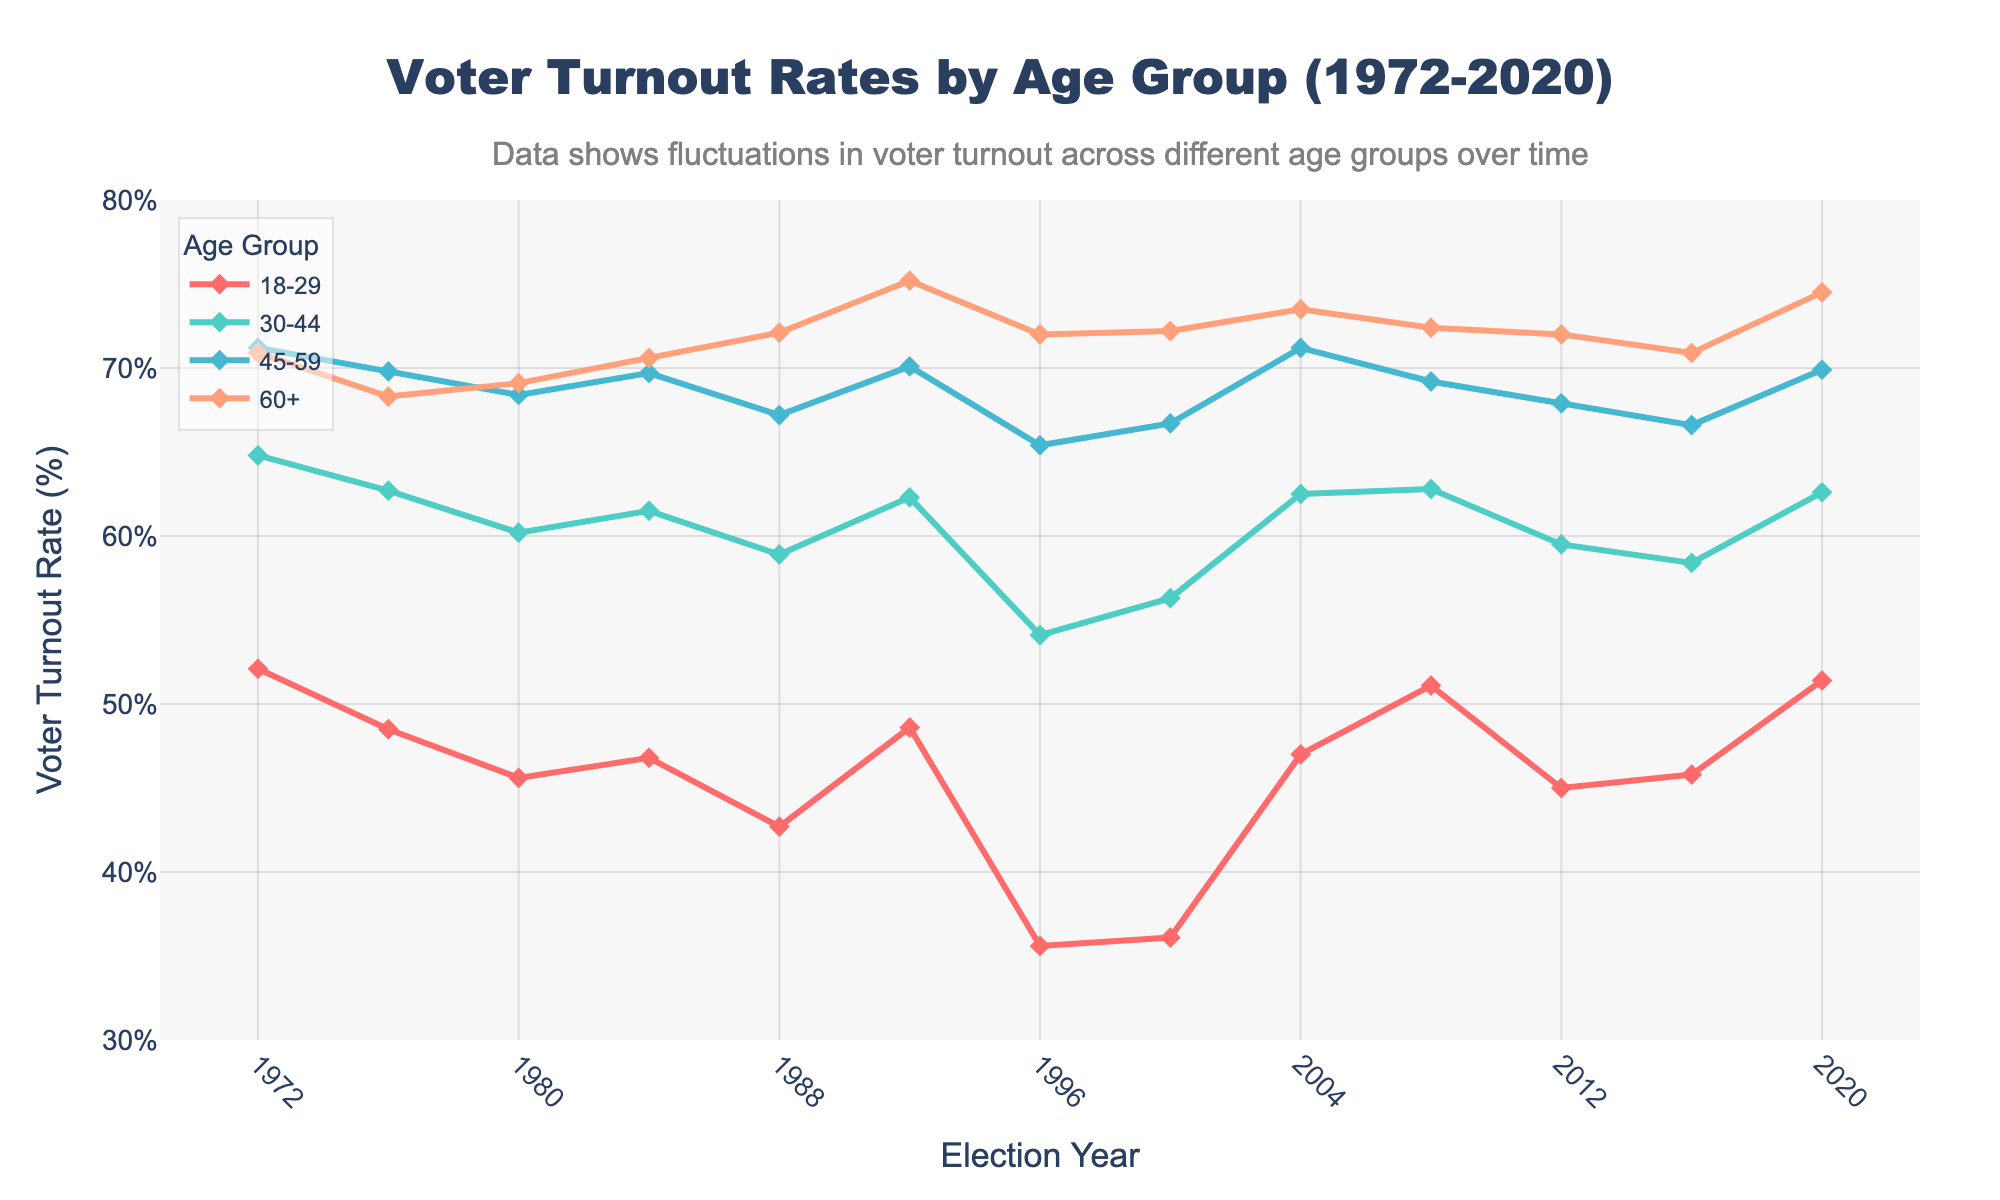What age group had the highest voter turnout in 1972? By looking at the data points labeled for the year 1972, the voter turnout rates for the age groups are 52.1% (18-29), 64.8% (30-44), 71.2% (45-59), and 70.9% (60+). Comparing these, the highest voter turnout was in the 45-59 age group, with 71.2%.
Answer: 45-59 Which age group experienced the biggest drop in voter turnout from 1992 to 1996? The voter turnout rates in 1992 and 1996 are as follows: 
- 18-29: 48.6% to 35.6% (a drop of 13.0%)
- 30-44: 62.3% to 54.1% (a drop of 8.2%)
- 45-59: 70.1% to 65.4% (a drop of 4.7%)
- 60+: 75.2% to 72.0% (a drop of 3.2%)
Comparing these decreases, the 18-29 age group had the largest drop of 13.0%.
Answer: 18-29 What is the average voter turnout rate for the age group 30-44 across all years displayed? The turnout rates for the 30-44 age group over the years are 64.8, 62.7, 60.2, 61.5, 58.9, 62.3, 54.1, 56.3, 62.5, 62.8, 59.5, 58.4, and 62.6. Summing these rates gives 796.6. Dividing by the number of data points (13) gives an average of 61.28%.
Answer: 61.3% How did the voter turnout for the 60+ age group change between the 1984 and 1988 elections? In 1984, the voter turnout for the 60+ age group was 70.6%, and in 1988 it was 72.1%. The change is calculated by subtracting the 1984 value from the 1988 value, i.e., 72.1% - 70.6% = 1.5%.
Answer: Increased by 1.5% Compare the voter turnout rates of the youngest (18-29) and oldest (60+) age groups in 2020. Which had the higher rate and by how much? In 2020, the voter turnout rate for the 18-29 age group was 51.4%, and for the 60+ age group, it was 74.5%. The 60+ age group had a higher rate. The difference is 74.5% - 51.4% = 23.1%.
Answer: 60+ by 23.1% Which age group shows the most consistent voter turnout over the 50 years displayed? To determine consistency, we can look at the fluctuation range of voter turnout rates for each age group. The ranges are approximately:
- 18-29: 52.1% - 35.6% = 16.5%
- 30-44: 64.8% - 54.1% = 10.7%
- 45-59: 71.2% - 65.4% = 5.8%
- 60+: 75.2% - 68.3% = 6.9%
The 45-59 age group has the smallest range of 5.8%, indicating the most consistent voter turnout.
Answer: 45-59 What is the median voter turnout rate for the 18-29 age group across all years displayed? The voter turnout rates for 18-29 over the years are: 52.1, 48.5, 45.6, 46.8, 42.7, 48.6, 35.6, 36.1, 47.0, 51.1, 45.0, 45.8, and 51.4. Sorting these values gives: 35.6, 36.1, 42.7, 45.0, 45.6, 45.8, 46.8, 47.0, 48.5, 48.6, 51.1, 51.4, 52.1. The median is the 7th value in ordered data (since 13 is odd), which is 46.8%.
Answer: 46.8% 